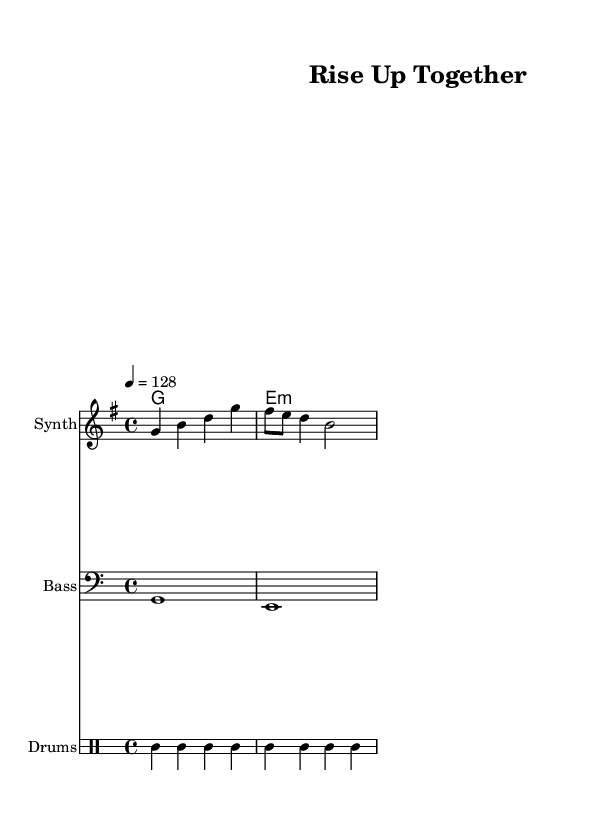What is the key signature of this music? The key signature is G major, which has one sharp (F#).
Answer: G major What is the time signature of this piece? The time signature is 4/4, which means there are four beats in each measure.
Answer: 4/4 What is the tempo of this music? The tempo is marked as 128 beats per minute, indicating a moderate dance pace.
Answer: 128 How many measures are in the melody? The melody consists of three measures as indicated by the grouping of notes.
Answer: 3 What type of drum is playing the bass in this track? The bass drum (bd) is playing on the beat, providing a foundational rhythm typical of dance music.
Answer: Bass drum What chords are used in this piece? The piece uses G major and E minor chords, which are common in uplifting dance tracks.
Answer: G major, E minor What is the instrumentation of this piece? The piece includes synthesizer, bass, and drums, showcasing a typical arrangement for dance music.
Answer: Synthesizer, bass, drums 